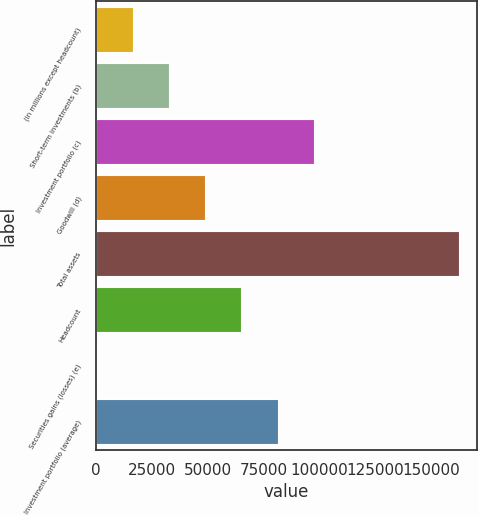<chart> <loc_0><loc_0><loc_500><loc_500><bar_chart><fcel>(in millions except headcount)<fcel>Short-term investments (b)<fcel>Investment portfolio (c)<fcel>Goodwill (d)<fcel>Total assets<fcel>Headcount<fcel>Securities gains (losses) (e)<fcel>Investment portfolio (average)<nl><fcel>16535.7<fcel>32724.4<fcel>97479.2<fcel>48913.1<fcel>162234<fcel>65101.8<fcel>347<fcel>81290.5<nl></chart> 